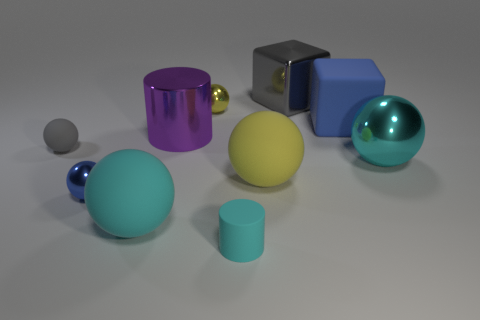How many things are either small things in front of the cyan metallic object or cubes?
Give a very brief answer. 4. What size is the yellow sphere that is the same material as the purple cylinder?
Make the answer very short. Small. Is the number of cylinders left of the gray matte object greater than the number of large cyan balls?
Provide a succinct answer. No. There is a tiny gray matte thing; is it the same shape as the gray object that is behind the yellow shiny ball?
Your answer should be very brief. No. How many large objects are green blocks or yellow metallic balls?
Offer a terse response. 0. There is a sphere that is the same color as the matte cube; what is its size?
Your answer should be very brief. Small. The shiny ball that is to the right of the metal block that is behind the small blue thing is what color?
Make the answer very short. Cyan. Does the large yellow sphere have the same material as the large cyan object on the right side of the cyan matte cylinder?
Give a very brief answer. No. What is the gray thing in front of the large gray metallic cube made of?
Offer a very short reply. Rubber. Is the number of large objects in front of the large yellow rubber sphere the same as the number of small spheres?
Provide a succinct answer. No. 